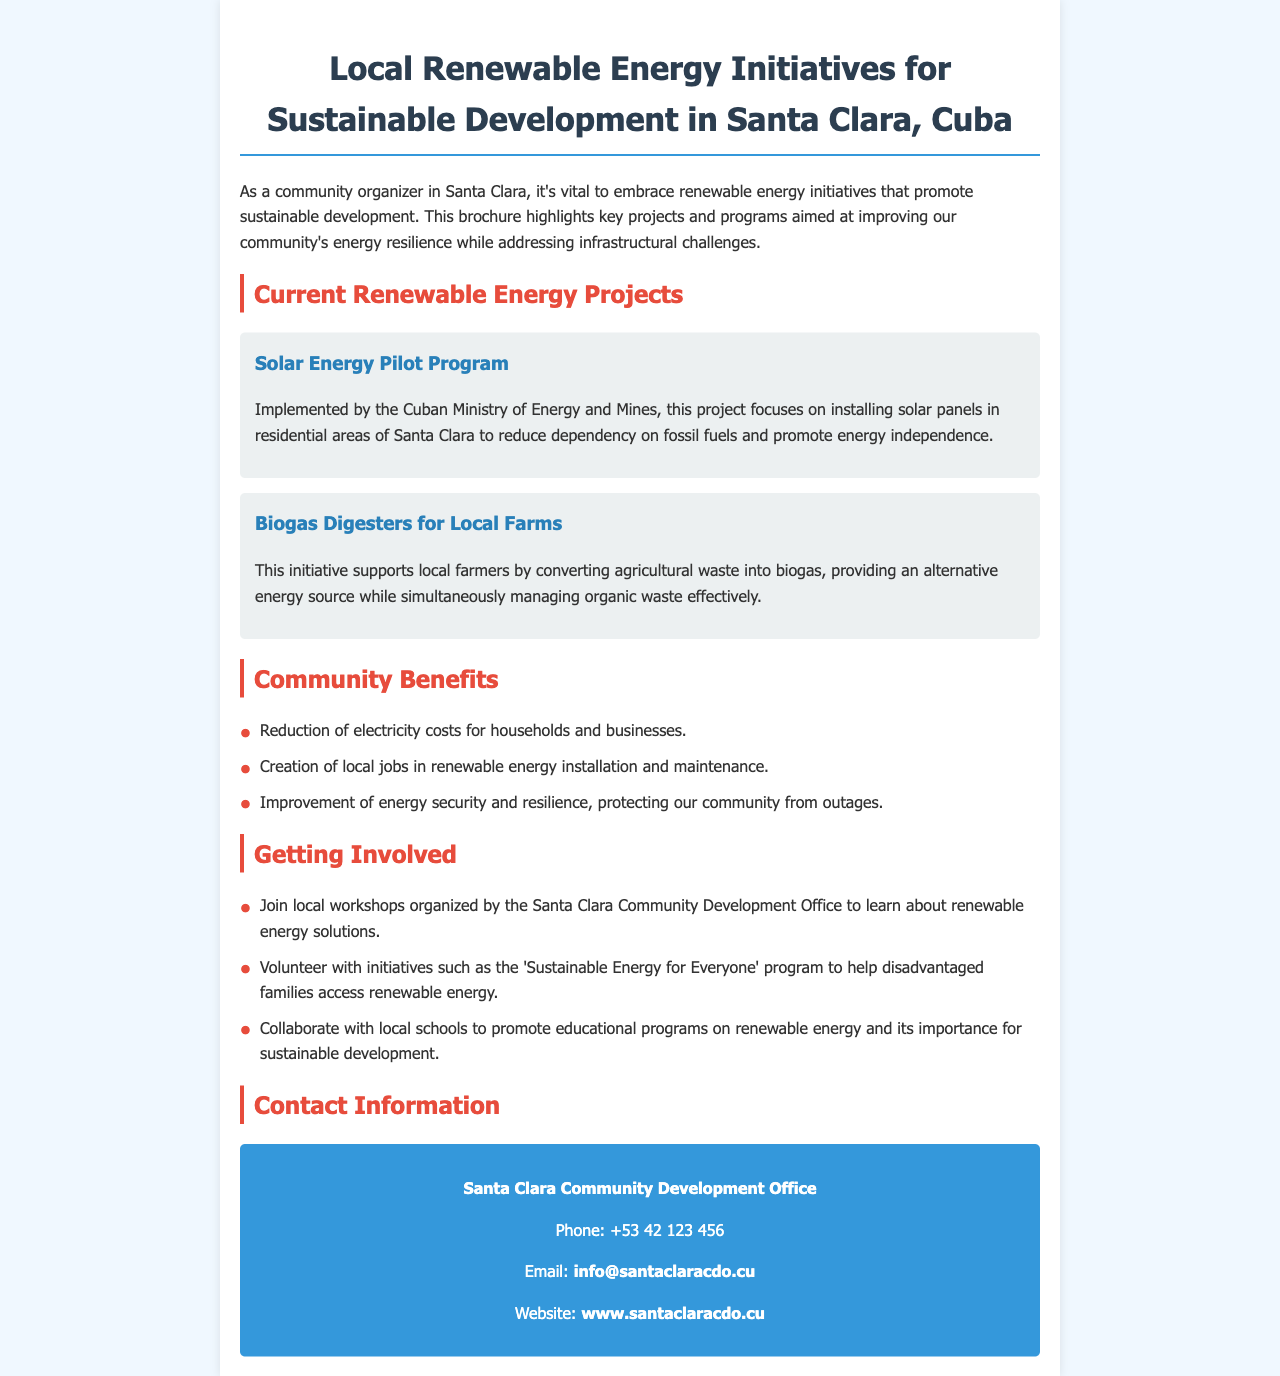What is the title of the brochure? The title of the brochure is presented prominently at the top of the document.
Answer: Local Renewable Energy Initiatives for Sustainable Development in Santa Clara, Cuba Who implemented the Solar Energy Pilot Program? The implementing body of the Solar Energy Pilot Program is mentioned in the project description.
Answer: Cuban Ministry of Energy and Mines What is one of the benefits mentioned for local farmers? The benefits for local farmers are listed in the project descriptions.
Answer: Alternative energy source How can community members learn about renewable energy solutions? The brochure provides ways for community members to engage with local initiatives.
Answer: Join local workshops What is the contact phone number for the Santa Clara Community Development Office? The brochure contains specific contact information including a phone number.
Answer: +53 42 123 456 What is a consequence of the initiatives for households? The document lists various benefits for households as a result of the projects.
Answer: Reduction of electricity costs What type of energy is produced from agricultural waste through the biogas digesters? The type of energy generated from agricultural waste is mentioned in the project summary.
Answer: Biogas Which program helps disadvantaged families access renewable energy? This initiative is explicitly referenced in the section about getting involved.
Answer: Sustainable Energy for Everyone 